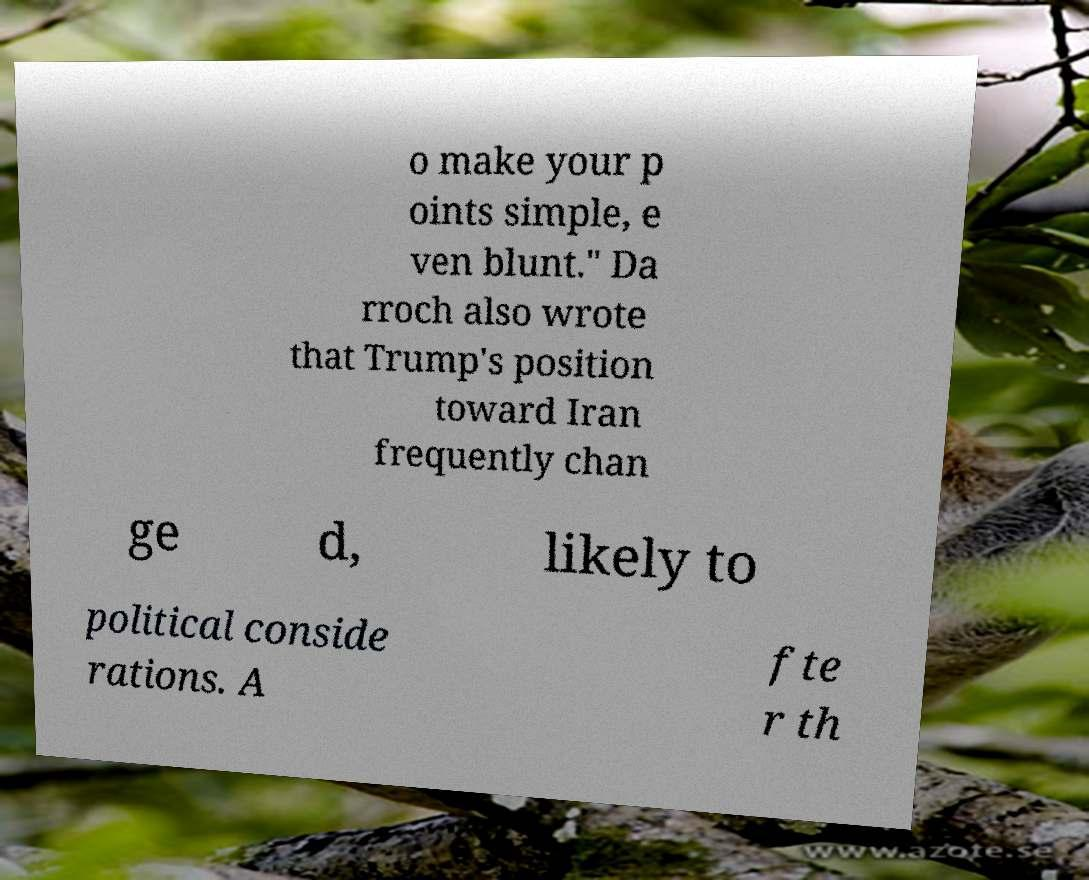I need the written content from this picture converted into text. Can you do that? o make your p oints simple, e ven blunt." Da rroch also wrote that Trump's position toward Iran frequently chan ge d, likely to political conside rations. A fte r th 